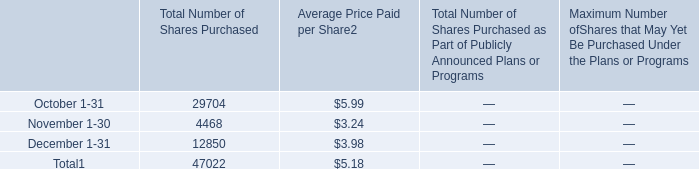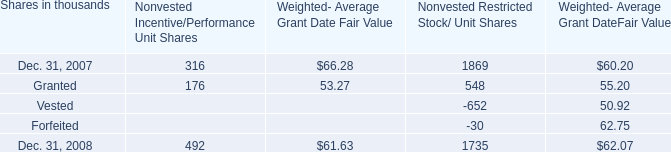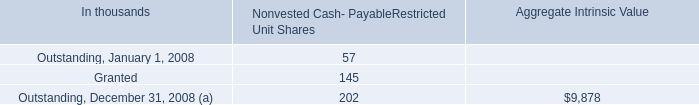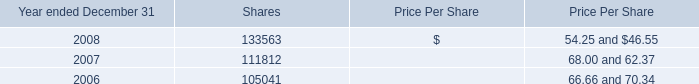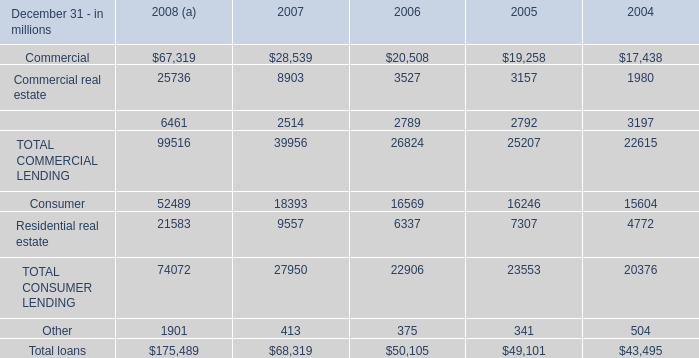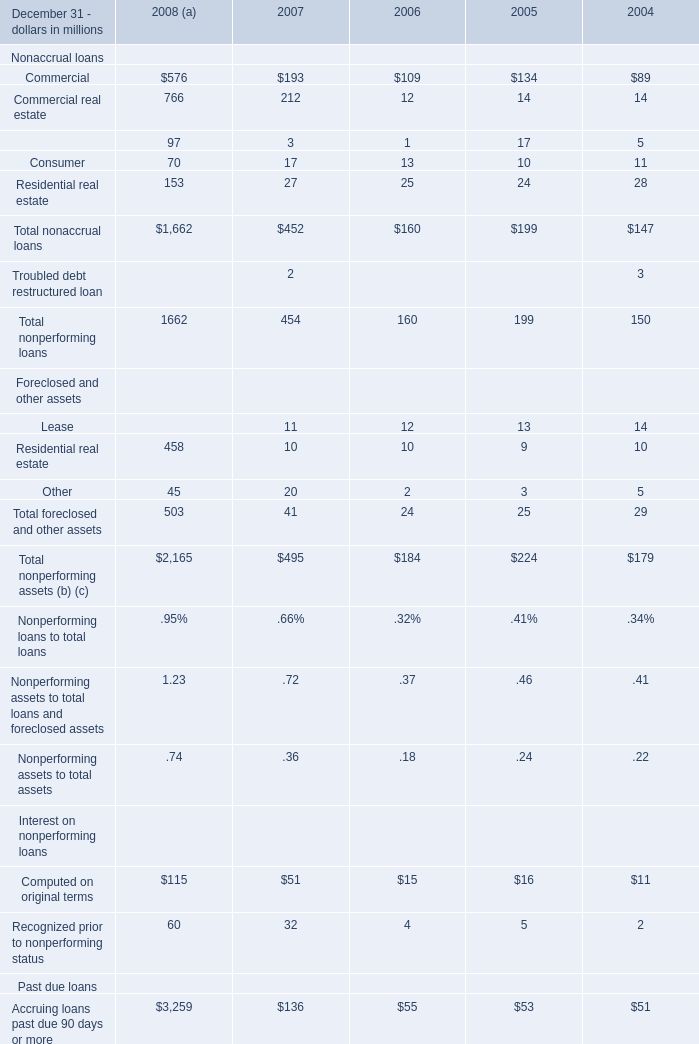What is the growing rate of Total foreclosed and other assets of Foreclosed and other assetsin the year with the most Commercial of Nonaccrual loans? 
Computations: ((503 - 41) / 503)
Answer: 0.91849. 